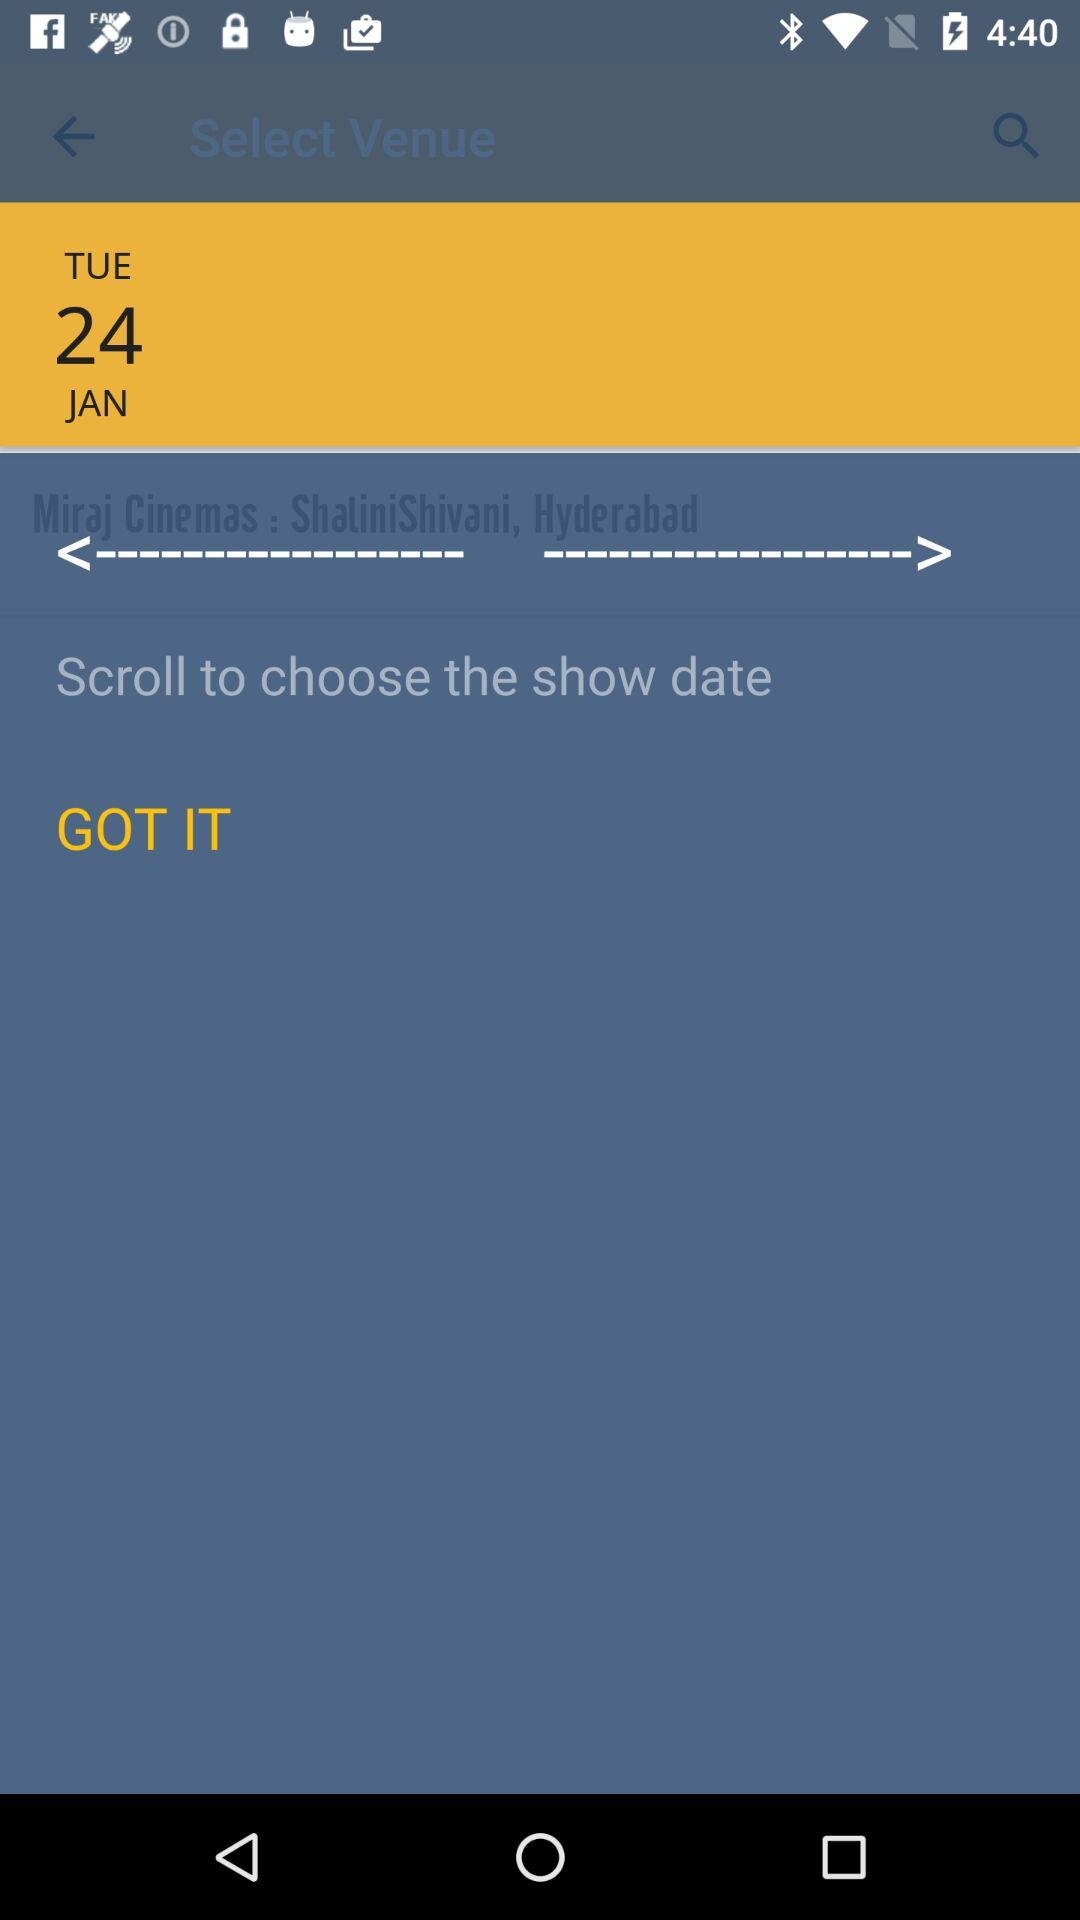What is the location? The location is Miraj Cinemas: ShatiniShivani, Hyderabad. 